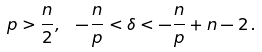Convert formula to latex. <formula><loc_0><loc_0><loc_500><loc_500>p > \frac { n } { 2 } , \ \, - \frac { n } { p } < \delta < - \frac { n } { p } + n - 2 \, .</formula> 